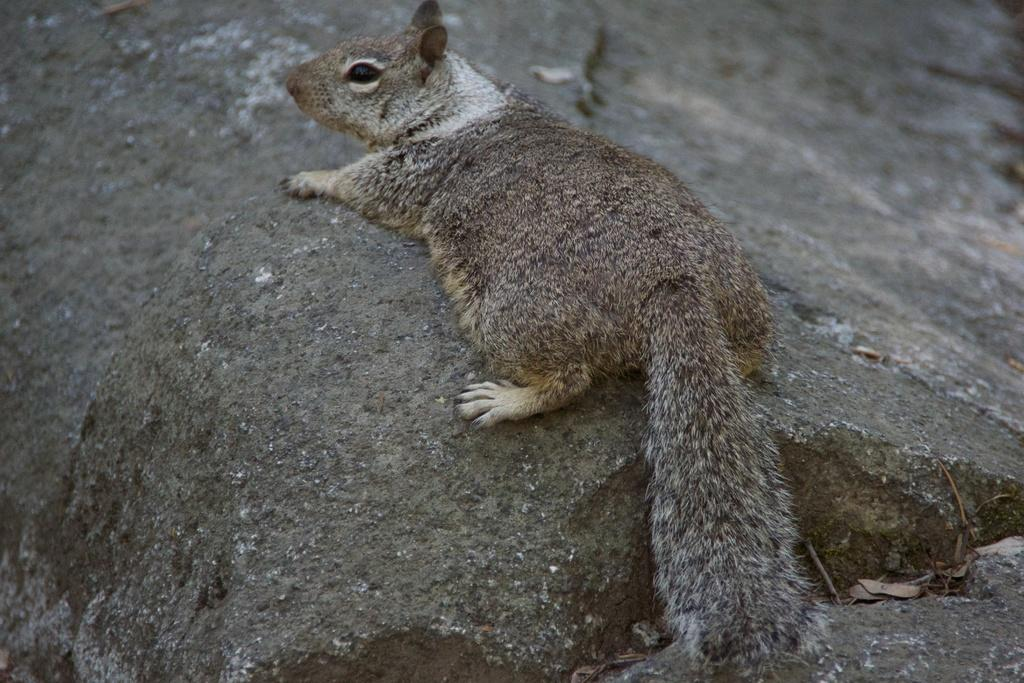Where was the picture taken? The picture was clicked outside. What can be seen in the image besides the outdoor setting? There is an animal in the image. What is the animal doing in the image? The animal is walking on a rock. Can you describe the background of the image? There is a rock visible in the background of the image. What letters can be seen on the animal's back in the image? There are no letters visible on the animal's back in the image. What is the chance of the animal stitching a quilt in the image? There is no indication of the animal stitching a quilt or any other activity involving letters or stitching in the image. 